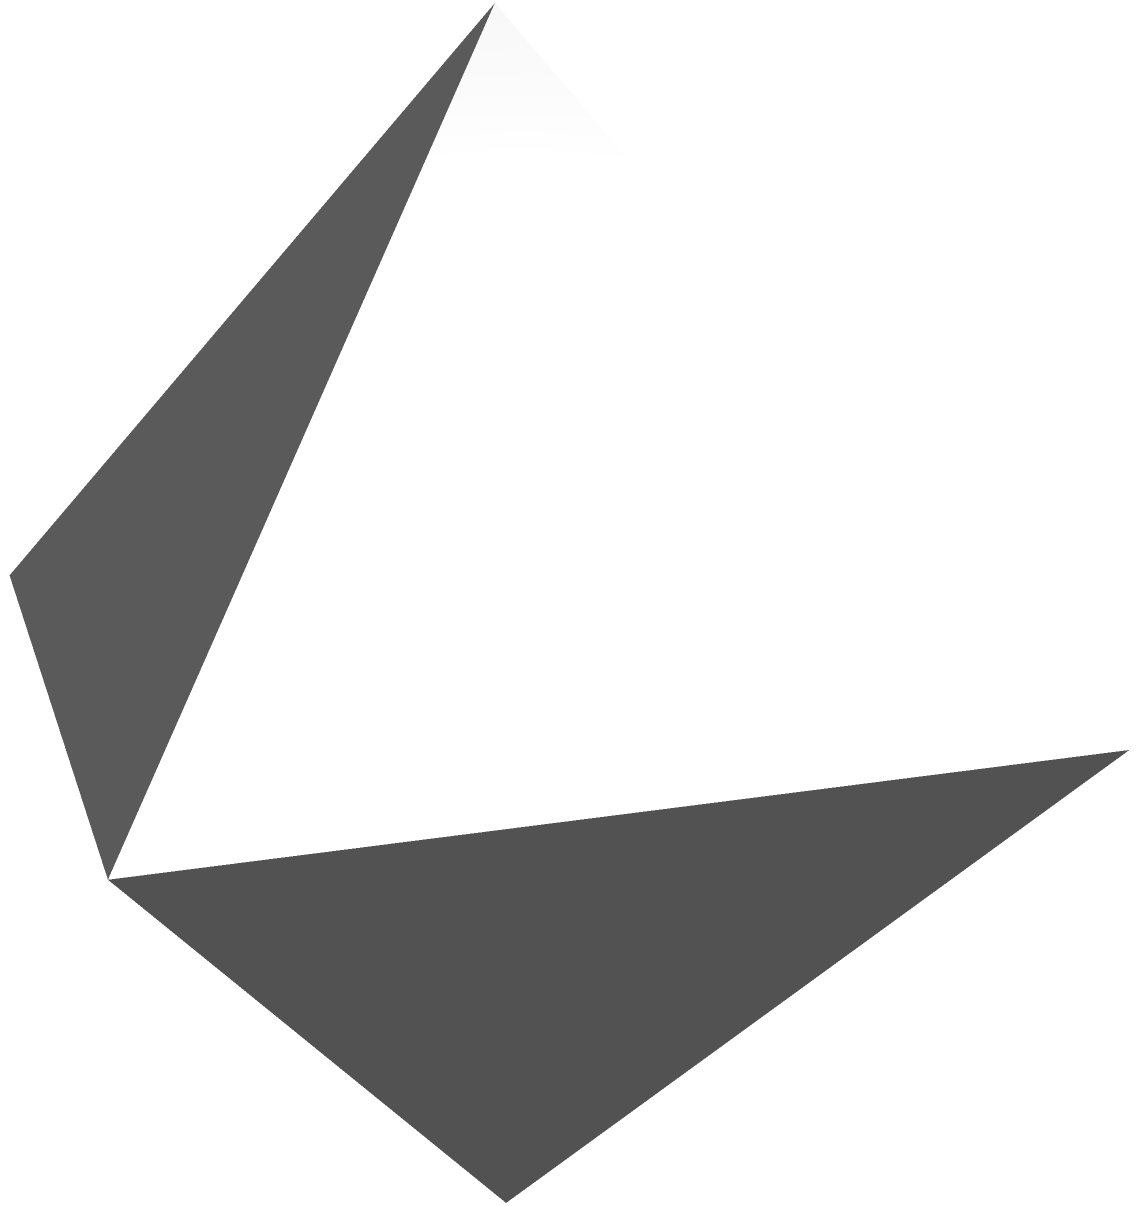In your latest video art installation exploring geometric forms, you've created a digital representation of a regular octahedron. The edge length of this octahedron is $a$ units. As part of your interactive exhibit, viewers are challenged to calculate the surface area of this shape. What is the surface area of the regular octahedron in terms of $a$? Let's approach this step-by-step:

1) First, recall that a regular octahedron has 8 equilateral triangular faces.

2) The surface area will be the sum of the areas of these 8 triangles.

3) For an equilateral triangle with side length $a$, the area is given by:

   $$A_{\text{triangle}} = \frac{\sqrt{3}}{4}a^2$$

4) Since there are 8 such triangles, the total surface area will be:

   $$SA_{\text{octahedron}} = 8 \times \frac{\sqrt{3}}{4}a^2$$

5) Simplifying:

   $$SA_{\text{octahedron}} = 2\sqrt{3}a^2$$

This formula represents the surface area of a regular octahedron with edge length $a$.
Answer: $2\sqrt{3}a^2$ 